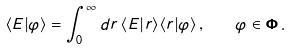Convert formula to latex. <formula><loc_0><loc_0><loc_500><loc_500>\langle E | \varphi \rangle = \int _ { 0 } ^ { \infty } d r \, \langle E | r \rangle \langle r | \varphi \rangle \, , \quad \varphi \in \mathbf \Phi \, .</formula> 